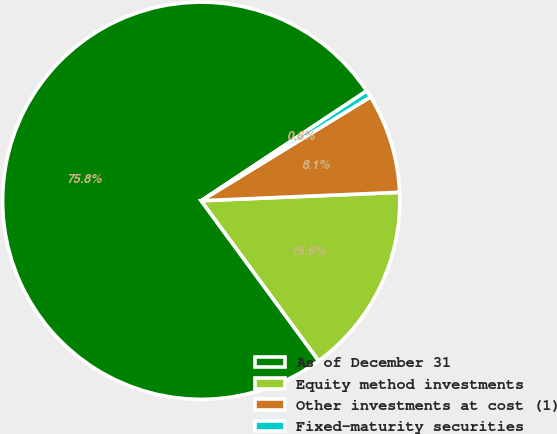Convert chart to OTSL. <chart><loc_0><loc_0><loc_500><loc_500><pie_chart><fcel>As of December 31<fcel>Equity method investments<fcel>Other investments at cost (1)<fcel>Fixed-maturity securities<nl><fcel>75.75%<fcel>15.6%<fcel>8.08%<fcel>0.57%<nl></chart> 